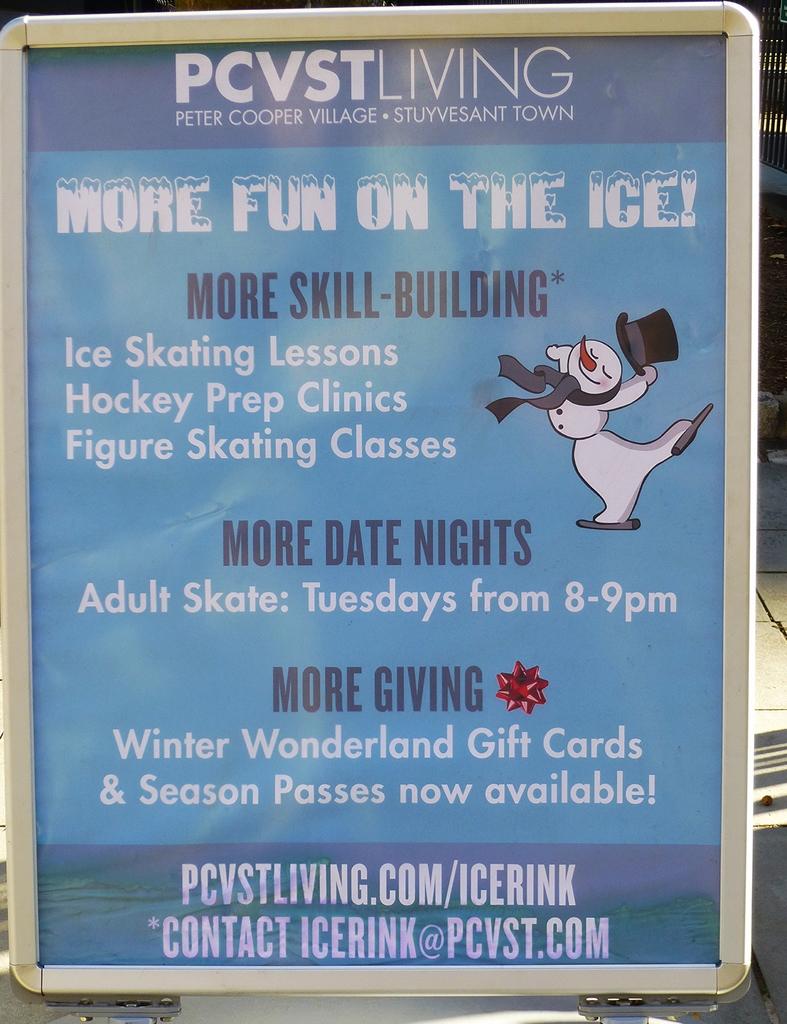What is the contact email?
Offer a very short reply. Icerink@pcvst.com. What is the name of the company being advertised?
Your response must be concise. Pcvst living. 